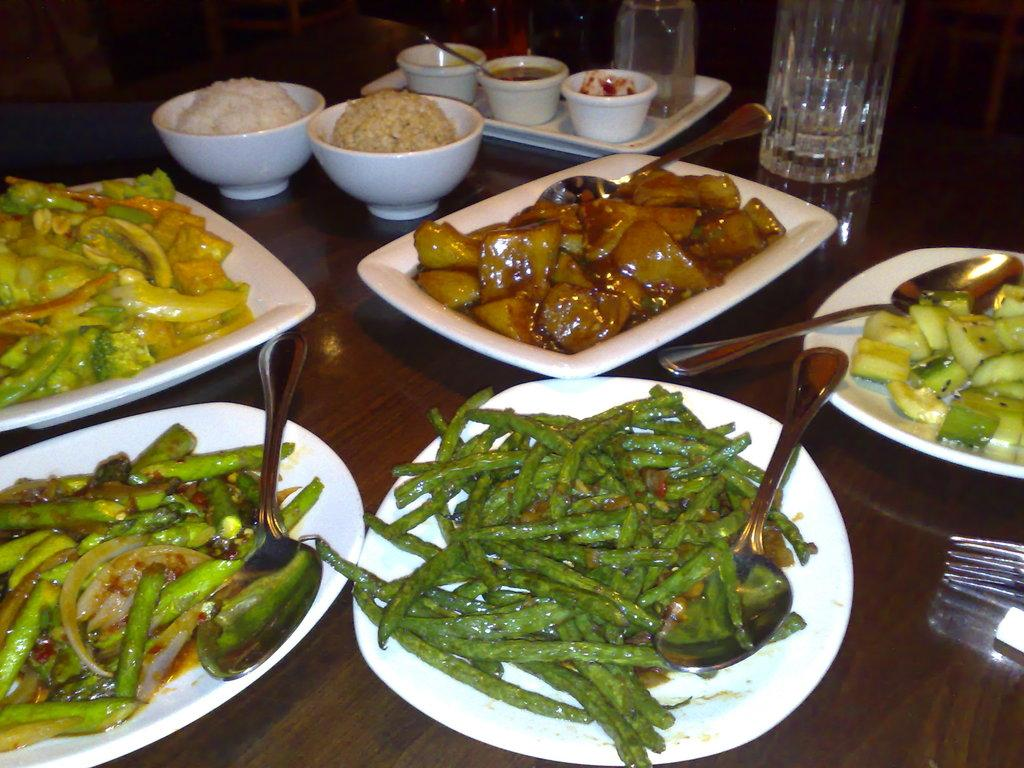What type of furniture is present in the image? There is a table in the image. What objects are placed on the table? There are plates, bowls, a jar, a tray, spoons, and a fork on the table. What can be found inside the plates and bowls? There are food items on the plates and in the bowls. How many types of utensils are visible on the table? There are spoons and a fork visible on the table. What is the plot of the story unfolding on the table in the image? There is no story or plot present in the image; it is a still life of objects on a table. 